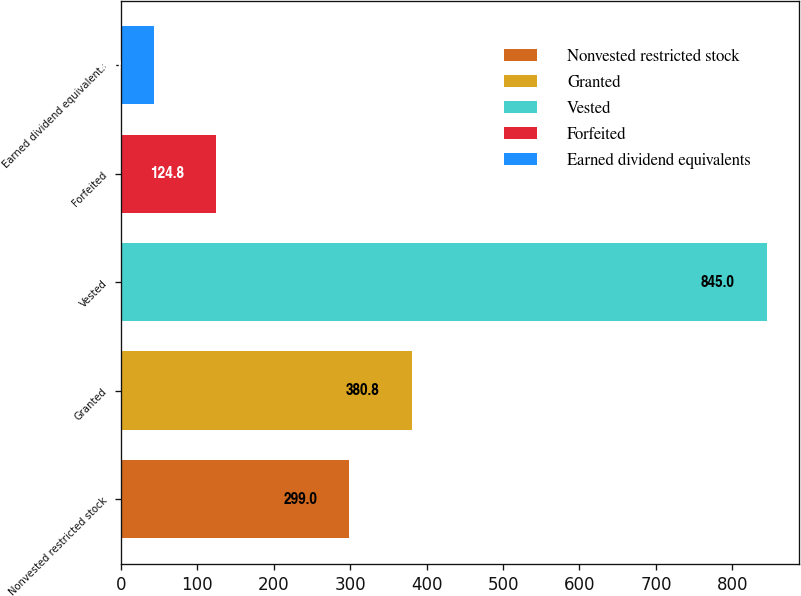<chart> <loc_0><loc_0><loc_500><loc_500><bar_chart><fcel>Nonvested restricted stock<fcel>Granted<fcel>Vested<fcel>Forfeited<fcel>Earned dividend equivalents<nl><fcel>299<fcel>380.8<fcel>845<fcel>124.8<fcel>43<nl></chart> 